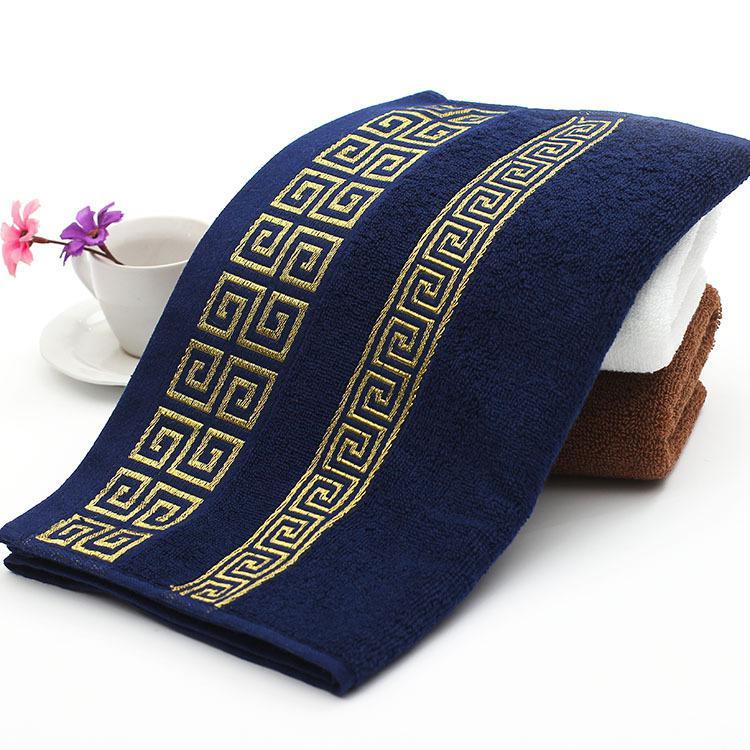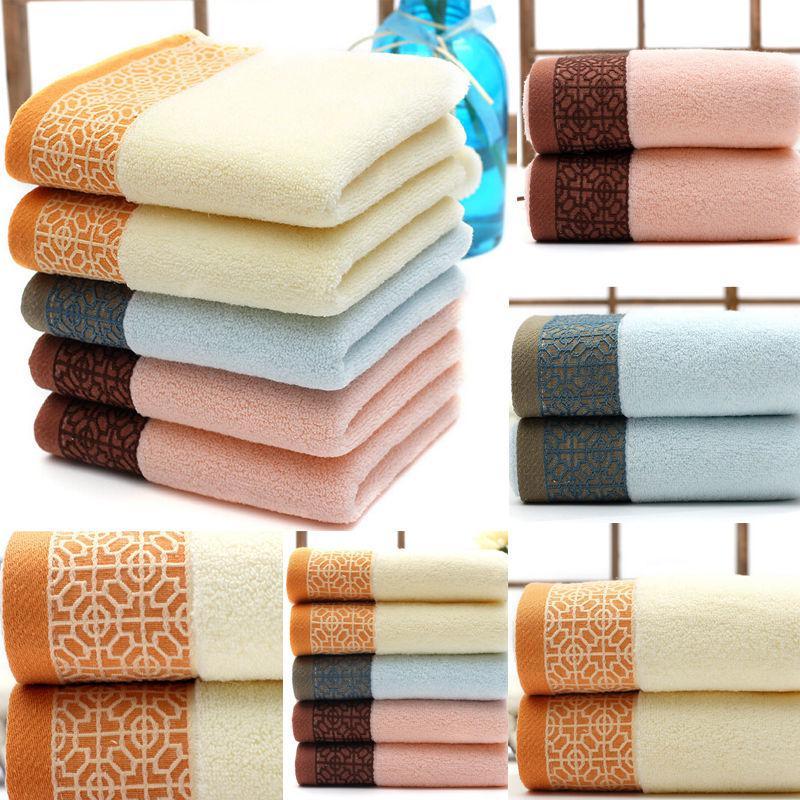The first image is the image on the left, the second image is the image on the right. Evaluate the accuracy of this statement regarding the images: "The left image shows exactly three towels, in navy, white and brown, with gold bands of """"Greek key"""" patterns on the towel's edge.". Is it true? Answer yes or no. Yes. The first image is the image on the left, the second image is the image on the right. Analyze the images presented: Is the assertion "In at least one image there is a tower of three folded towels." valid? Answer yes or no. No. 